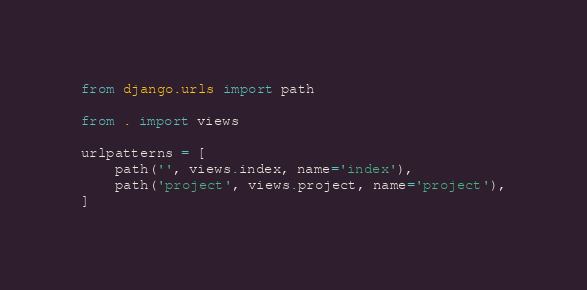Convert code to text. <code><loc_0><loc_0><loc_500><loc_500><_Python_>from django.urls import path

from . import views

urlpatterns = [
    path('', views.index, name='index'),
    path('project', views.project, name='project'),
]
</code> 